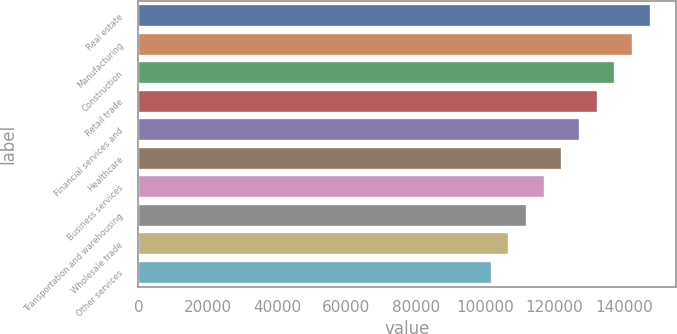Convert chart. <chart><loc_0><loc_0><loc_500><loc_500><bar_chart><fcel>Real estate<fcel>Manufacturing<fcel>Construction<fcel>Retail trade<fcel>Financial services and<fcel>Healthcare<fcel>Business services<fcel>Transportation and warehousing<fcel>Wholesale trade<fcel>Other services<nl><fcel>147758<fcel>142663<fcel>137568<fcel>132473<fcel>127378<fcel>122283<fcel>117188<fcel>112093<fcel>106998<fcel>101903<nl></chart> 